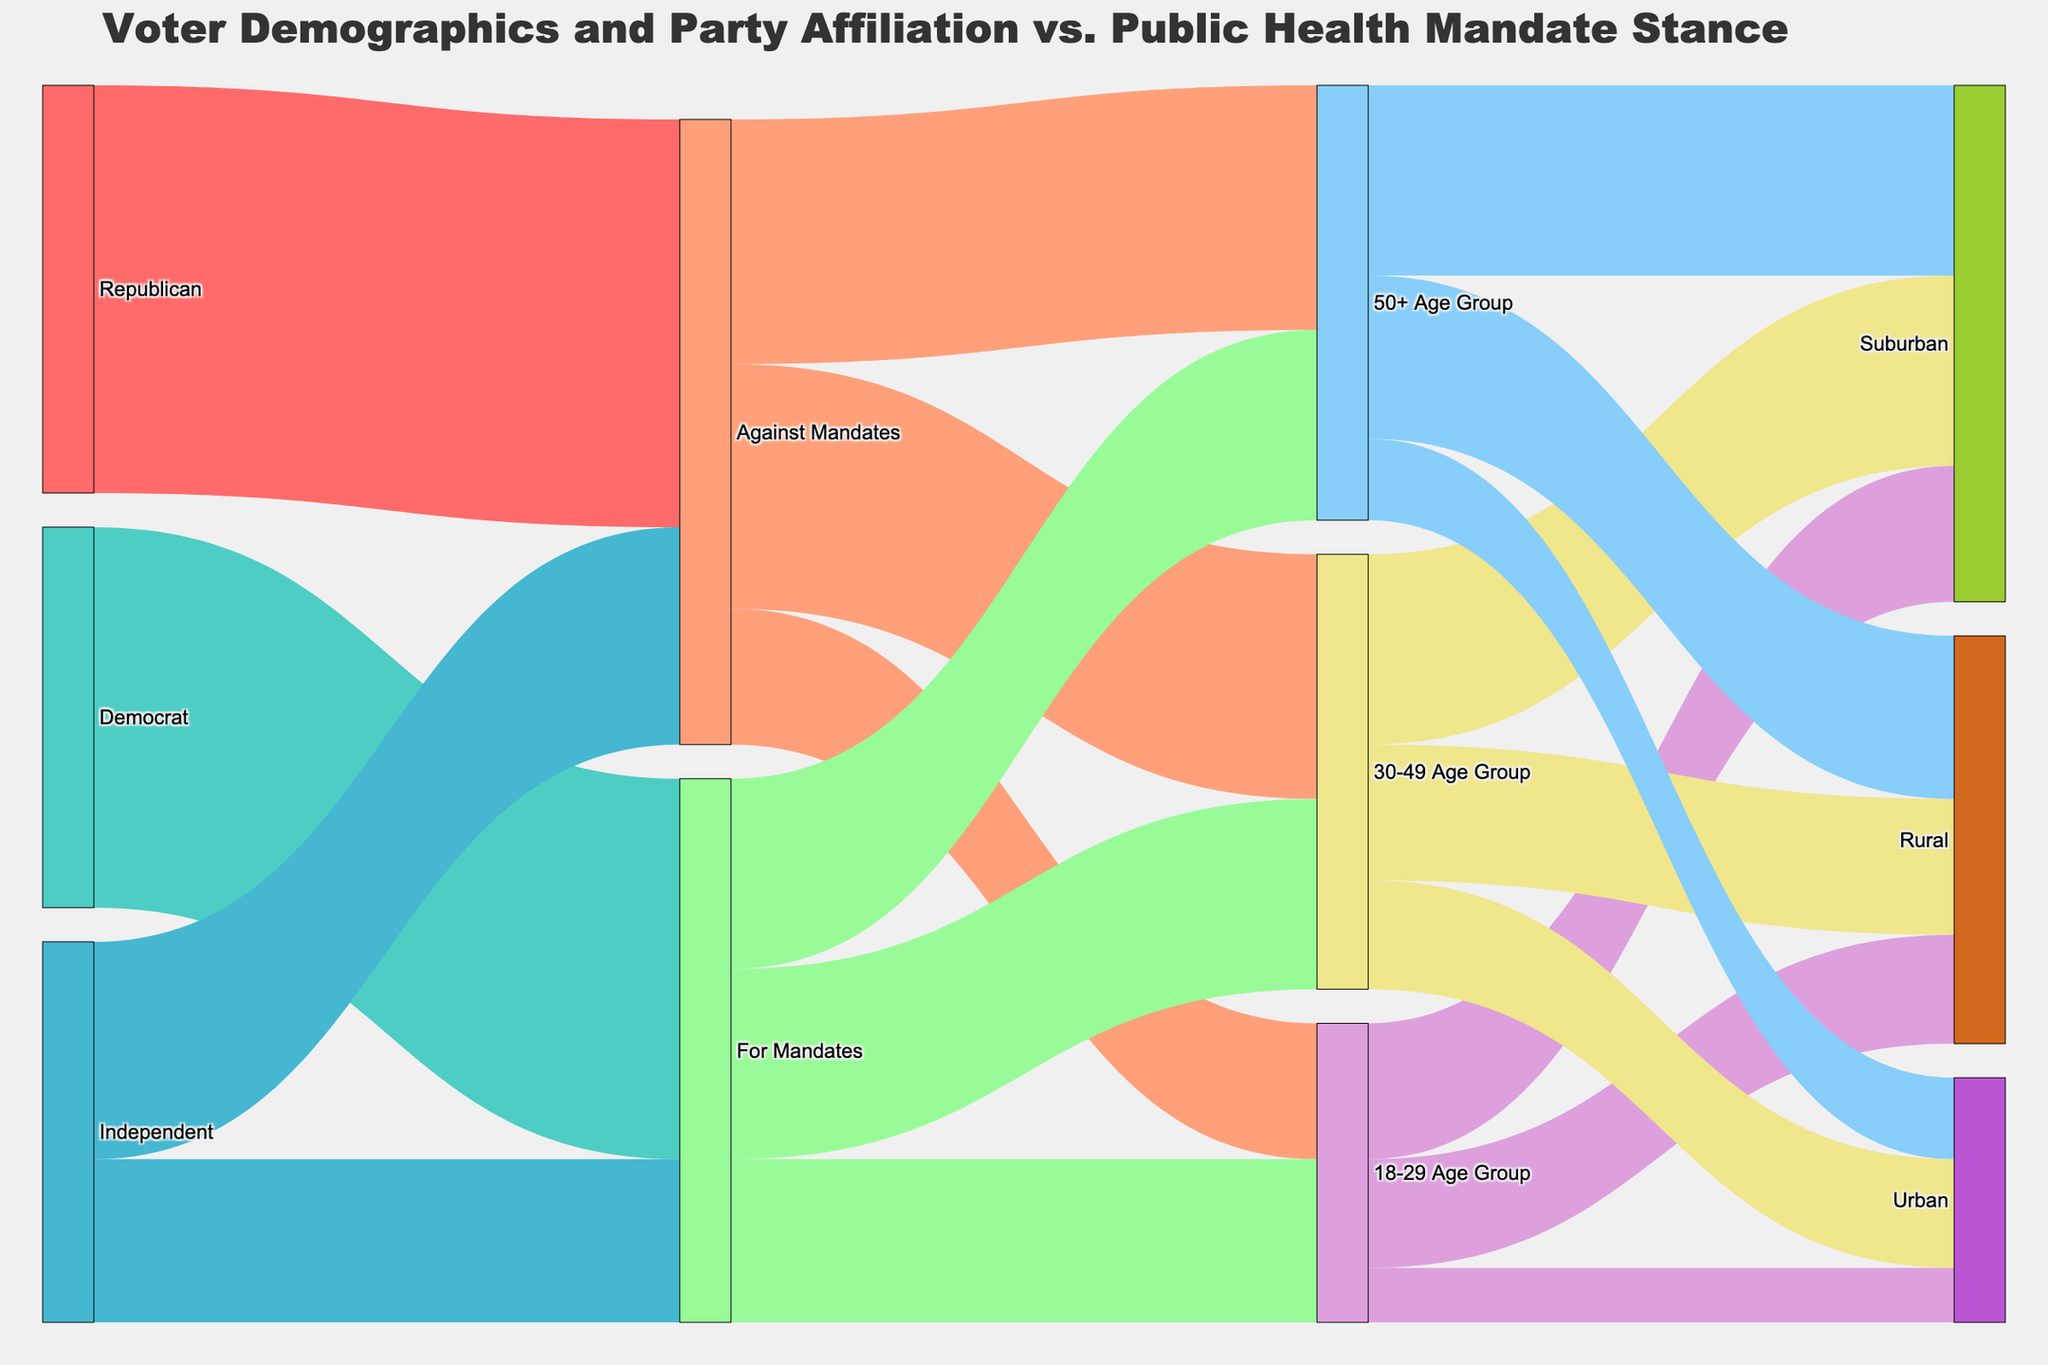What is the title of the diagram? The title is often at the top of a diagram and provides a summary of what the figure is about.
Answer: "Voter Demographics and Party Affiliation vs. Public Health Mandate Stance" Which political party has the most supporters against mandates? Find the largest value among the links connected to the "Against Mandates" node from the political parties. The largest value is 75 from Republicans.
Answer: Republicans How many Independent voters are for mandates compared to against mandates? Look at the values connecting Independent to "For Mandates" and "Against Mandates". "For Mandates" is 30 and "Against Mandates" is 40. Comparison: 30 vs 40.
Answer: 30 for mandates, 40 against mandates What age group has the highest number of people against mandates? Look at the links from "Against Mandates" to different age groups. The values are 25 (18-29), 45 (30-49), and 45 (50+). Both 30-49 and 50+ have 45.
Answer: 30-49 and 50+ Age Groups Which age group in the "For Mandates" category has the smallest number? Compare the values from "For Mandates" to different age groups: 18-29 (30), 30-49 (35), 50+ (35). The lowest number is for age group 18-29.
Answer: 18-29 Age Group In the age group 18-29, which area has the highest number of people? Look at the values connected to "18-29 Age Group" for different areas: Rural (20), Suburban (25), Urban (10). Suburban has the highest value.
Answer: Suburban How many people aged 30-49 are from rural areas? Find the value connecting "30-49 Age Group" to "Rural". The value is 25.
Answer: 25 Which combination of age group and stance on mandates has the highest value? Identify the highest value among the links between age groups and mandate stances. The highest value is 45 (30-49 Against Mandates and 50+ Against Mandates).
Answer: 30-49 Against Mandates and 50+ Against Mandates What is the total number of votes from rural areas? Add up the values connected to "Rural" from different age groups: 20 (18-29), 25 (30-49), 30 (50+), giving 20 + 25 + 30 = 75.
Answer: 75 